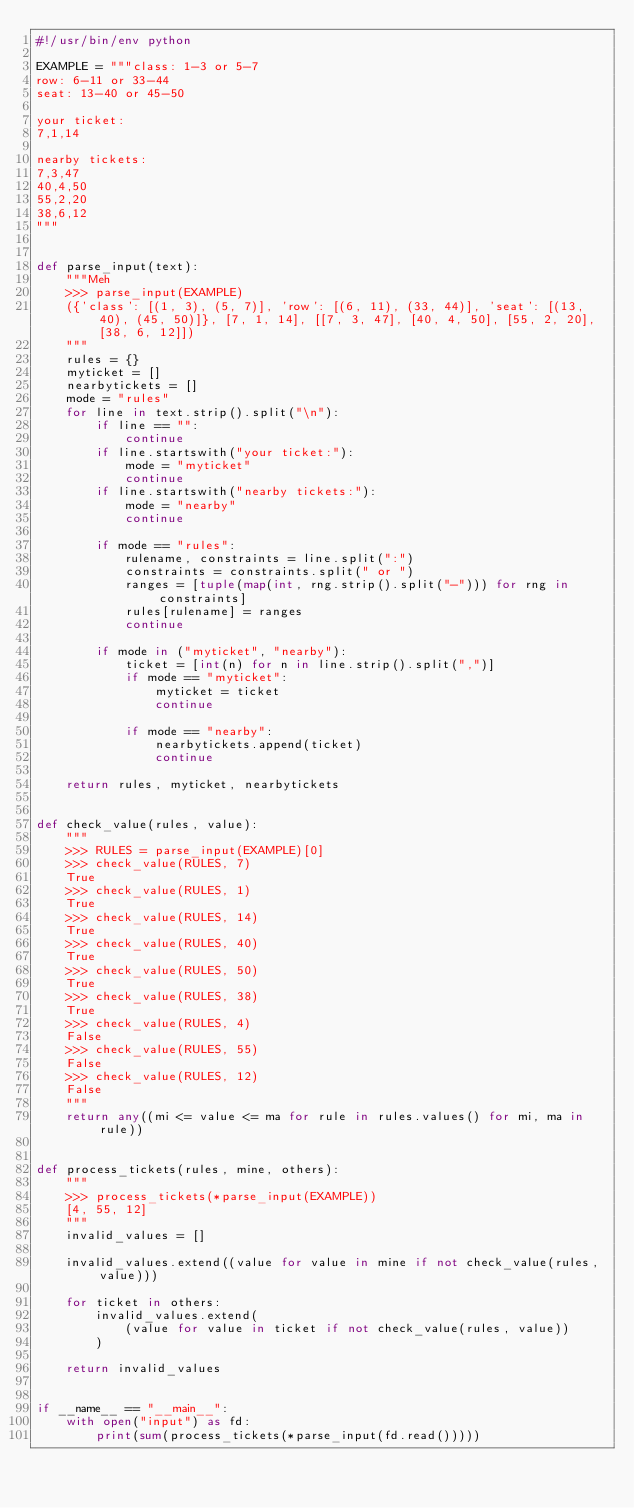<code> <loc_0><loc_0><loc_500><loc_500><_Python_>#!/usr/bin/env python

EXAMPLE = """class: 1-3 or 5-7
row: 6-11 or 33-44
seat: 13-40 or 45-50

your ticket:
7,1,14

nearby tickets:
7,3,47
40,4,50
55,2,20
38,6,12
"""


def parse_input(text):
    """Meh
    >>> parse_input(EXAMPLE)
    ({'class': [(1, 3), (5, 7)], 'row': [(6, 11), (33, 44)], 'seat': [(13, 40), (45, 50)]}, [7, 1, 14], [[7, 3, 47], [40, 4, 50], [55, 2, 20], [38, 6, 12]])
    """
    rules = {}
    myticket = []
    nearbytickets = []
    mode = "rules"
    for line in text.strip().split("\n"):
        if line == "":
            continue
        if line.startswith("your ticket:"):
            mode = "myticket"
            continue
        if line.startswith("nearby tickets:"):
            mode = "nearby"
            continue

        if mode == "rules":
            rulename, constraints = line.split(":")
            constraints = constraints.split(" or ")
            ranges = [tuple(map(int, rng.strip().split("-"))) for rng in constraints]
            rules[rulename] = ranges
            continue

        if mode in ("myticket", "nearby"):
            ticket = [int(n) for n in line.strip().split(",")]
            if mode == "myticket":
                myticket = ticket
                continue

            if mode == "nearby":
                nearbytickets.append(ticket)
                continue

    return rules, myticket, nearbytickets


def check_value(rules, value):
    """
    >>> RULES = parse_input(EXAMPLE)[0]
    >>> check_value(RULES, 7)
    True
    >>> check_value(RULES, 1)
    True
    >>> check_value(RULES, 14)
    True
    >>> check_value(RULES, 40)
    True
    >>> check_value(RULES, 50)
    True
    >>> check_value(RULES, 38)
    True
    >>> check_value(RULES, 4)
    False
    >>> check_value(RULES, 55)
    False
    >>> check_value(RULES, 12)
    False
    """
    return any((mi <= value <= ma for rule in rules.values() for mi, ma in rule))


def process_tickets(rules, mine, others):
    """
    >>> process_tickets(*parse_input(EXAMPLE))
    [4, 55, 12]
    """
    invalid_values = []

    invalid_values.extend((value for value in mine if not check_value(rules, value)))

    for ticket in others:
        invalid_values.extend(
            (value for value in ticket if not check_value(rules, value))
        )

    return invalid_values


if __name__ == "__main__":
    with open("input") as fd:
        print(sum(process_tickets(*parse_input(fd.read()))))
</code> 